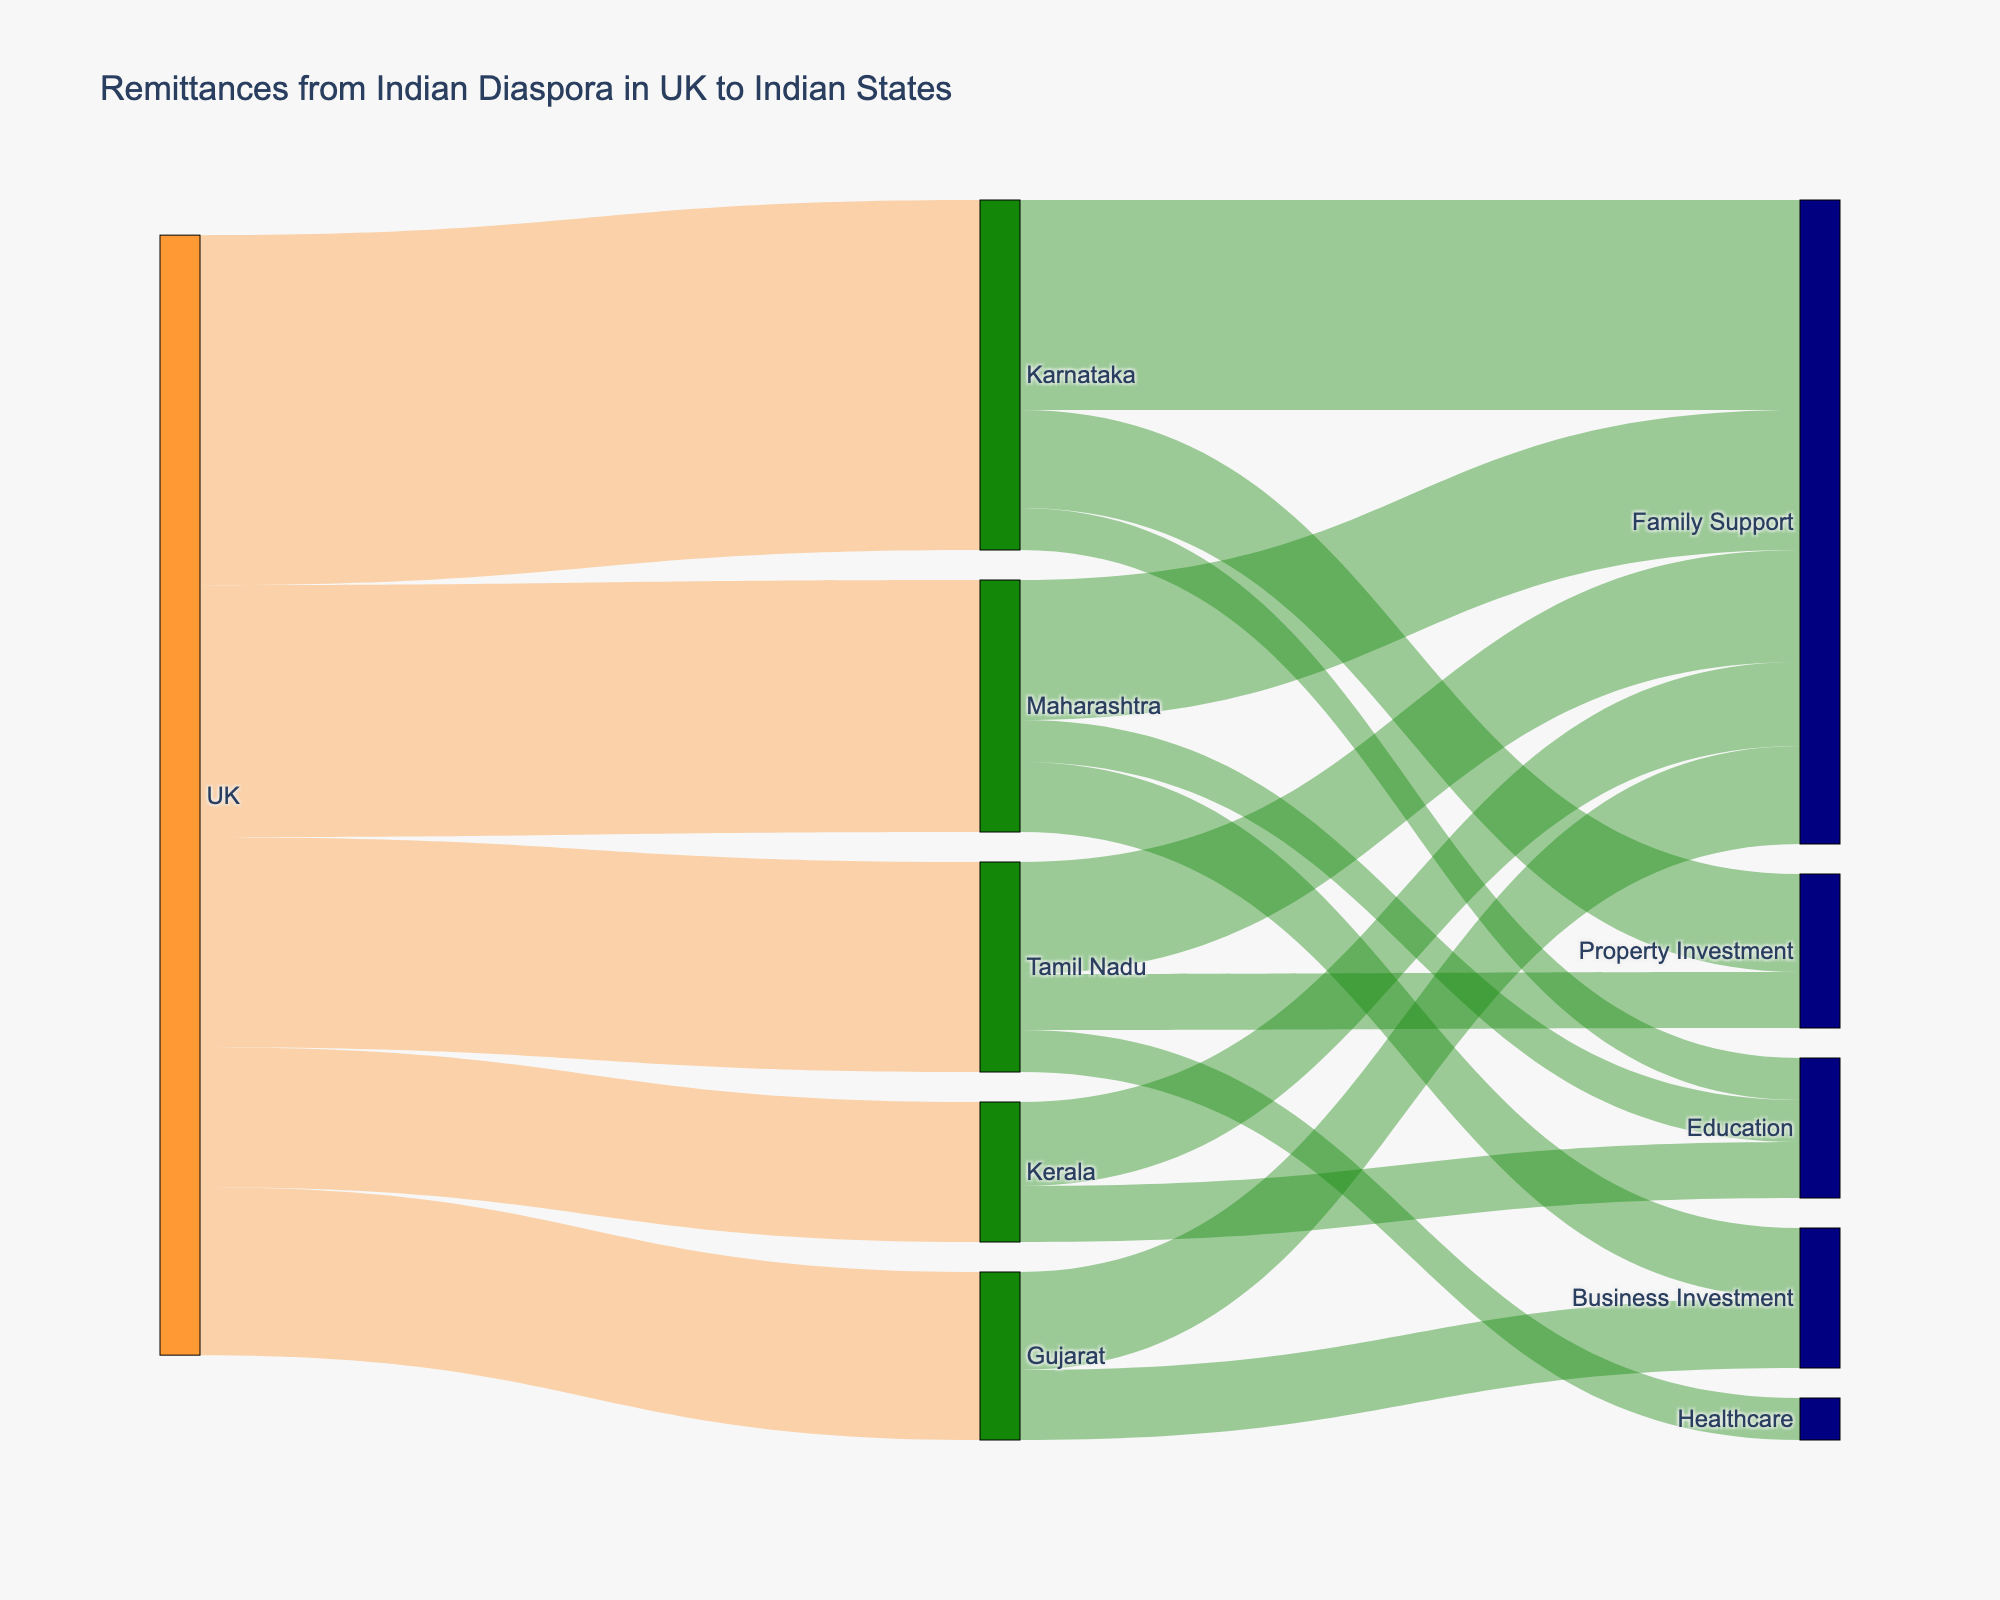What is the total amount of remittances sent from the UK to Indian states? Adding up the remittances: Karnataka (250) + Maharashtra (180) + Tamil Nadu (150) + Gujarat (120) + Kerala (100) gives a total
Answer: 800 Which state received the highest remittance from the UK? By comparing the amounts received by each state: Karnataka (250), Maharashtra (180), Tamil Nadu (150), Gujarat (120), Kerala (100), Karnataka received the highest
Answer: Karnataka How much remittance was sent to Karnataka for family support? From the figure, the remittance for family support to Karnataka is 150
Answer: 150 What is the combined remittance for education purposes across all states? Summing up remittances for education: Karnataka (30) + Maharashtra (30) + Kerala (40) = 100
Answer: 100 Which state has the highest remittance for business investments? Only Maharashtra (50) and Gujarat (50) have remittances for business investments, both are equal at 50 each
Answer: Maharashtra, Gujarat How does the remittance for property investment in Tamil Nadu compare to Karnataka? Property investment amounts: Karnataka (70) compared to Tamil Nadu (40), Karnataka is higher
Answer: Karnataka What is the proportion of remittance received by Kerala for family support out of its total remittance? Kerala family support is 60, total for Kerala is 100, so proportion is 60/100 = 0.6 or 60%
Answer: 60% How much total remittance is sent for family support across all states? Summing up family support remittances: Karnataka (150) + Maharashtra (100) + Tamil Nadu (80) + Gujarat (70) + Kerala (60) = 460
Answer: 460 What's the difference between the total remittance received by Maharashtra and Tamil Nadu? Maharashtra received 180, Tamil Nadu received 150, so difference is 180 - 150 = 30
Answer: 30 